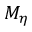<formula> <loc_0><loc_0><loc_500><loc_500>M _ { \eta }</formula> 